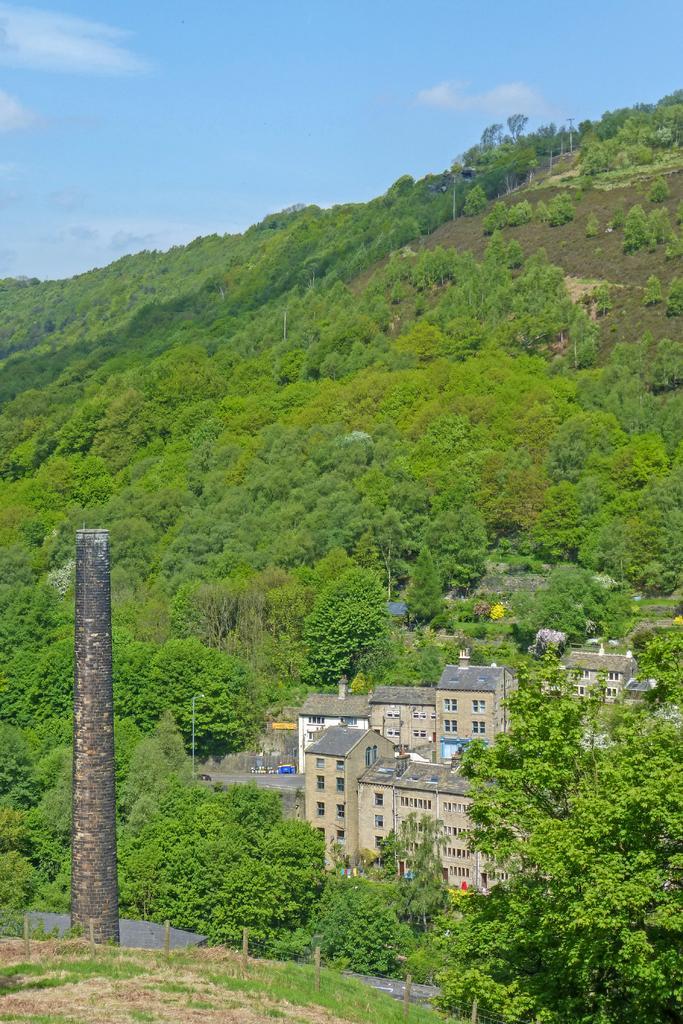Can you describe this image briefly? This image consists of a mountain which is covered with plants and trees. In the middle, there is a building. To the left, there is a pole which looks like a chimney. At the bottom, there is ground. 